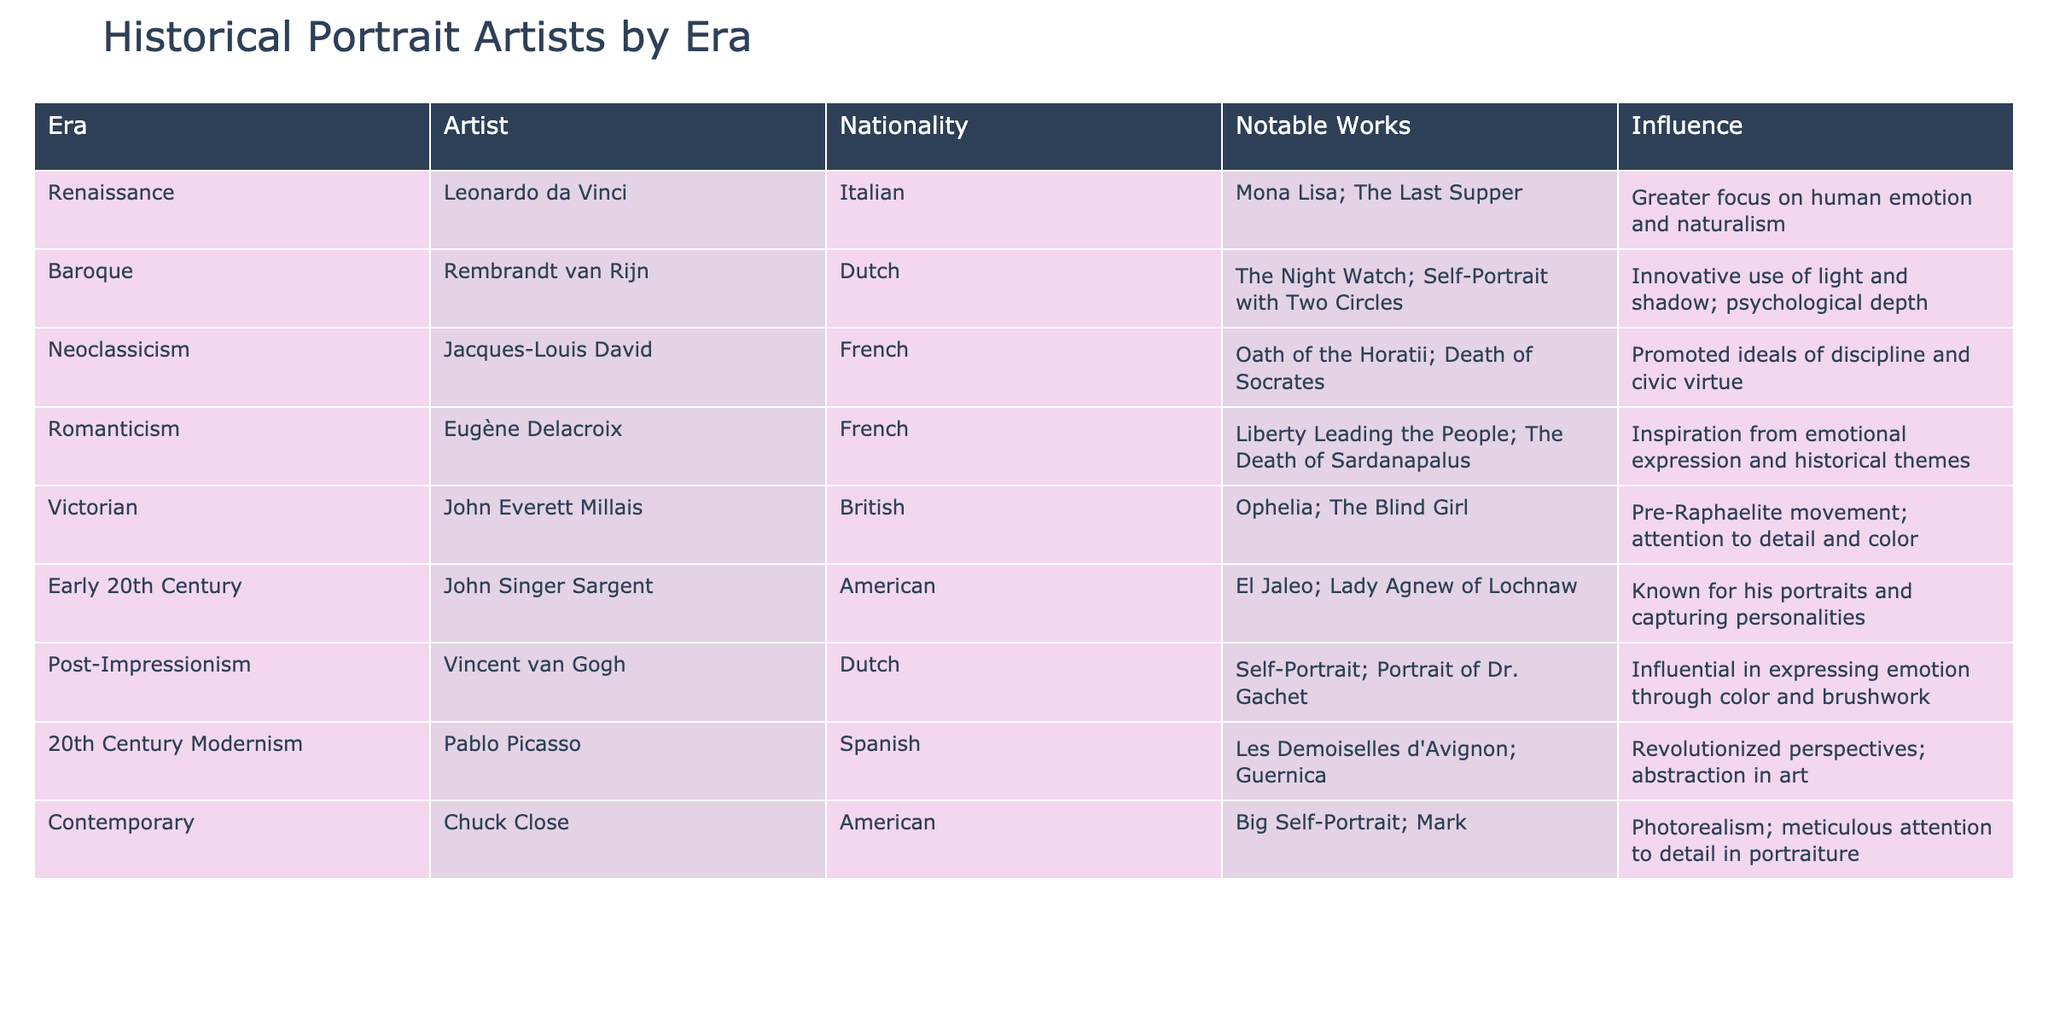What is the nationality of Leonardo da Vinci? The table indicates that Leonardo da Vinci is listed under the Renaissance era and his nationality is Italian.
Answer: Italian Which artist is known for the work "Liberty Leading the People"? The table shows that "Liberty Leading the People" was created by Eugène Delacroix, who is associated with the Romanticism era.
Answer: Eugène Delacroix How many artists are from the French nationality? The table lists five artists, two of whom are French: Jacques-Louis David and Eugène Delacroix. Therefore, the count is 2.
Answer: 2 Is Rembrandt van Rijn associated with the Neoclassicism era? According to the table, Rembrandt van Rijn is listed under the Baroque era, not Neoclassicism.
Answer: No Which artist had a notable influence on emotional expression through color and brushwork? The table states that Vincent van Gogh had a significant influence in expressing emotion through color and brushwork under the Post-Impressionism era.
Answer: Vincent van Gogh What notable works are attributed to John Singer Sargent? The table specifically lists "El Jaleo" and "Lady Agnew of Lochnaw" as notable works by John Singer Sargent.
Answer: El Jaleo; Lady Agnew of Lochnaw Who are the artists from the British and Dutch nationalities combined? The table identifies John Everett Millais, who is British, and Rembrandt van Rijn and Vincent van Gogh, both Dutch. Therefore, the combined list includes three artists.
Answer: 3 What is the primary focus of artists from the Renaissance era? The table indicates the influence of the Renaissance artists, emphasizing greater focus on human emotion and naturalism as a hallmark of this era.
Answer: Greater focus on human emotion and naturalism Which artist is recognized for revolutionizing perspectives in art? The table specifies that Pablo Picasso revolutionized perspectives and is associated with 20th Century Modernism.
Answer: Pablo Picasso 